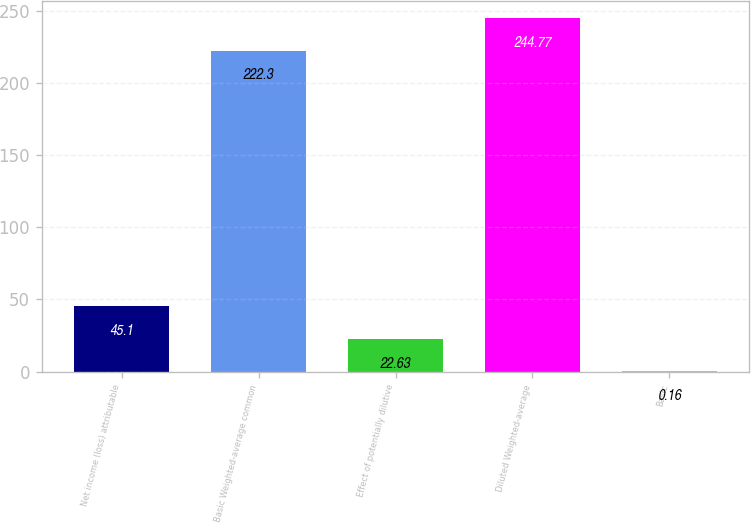<chart> <loc_0><loc_0><loc_500><loc_500><bar_chart><fcel>Net income (loss) attributable<fcel>Basic Weighted-average common<fcel>Effect of potentially dilutive<fcel>Diluted Weighted-average<fcel>Basic<nl><fcel>45.1<fcel>222.3<fcel>22.63<fcel>244.77<fcel>0.16<nl></chart> 